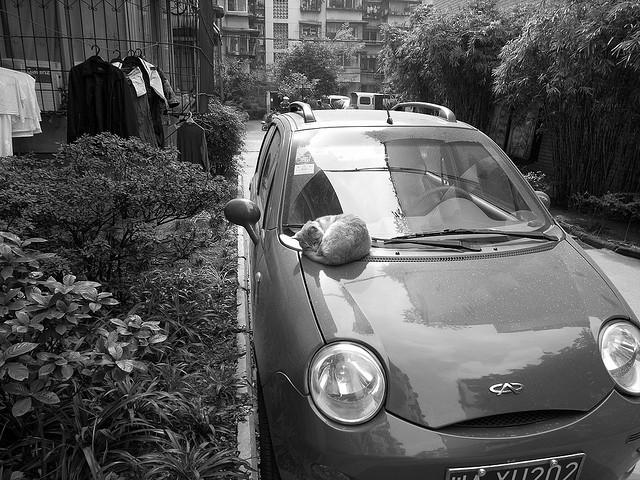Is that a dog sleeping on the car?
Be succinct. No. Is it obvious the car is supposed to be blue?
Write a very short answer. No. What type of car is that?
Quick response, please. Foreign. 